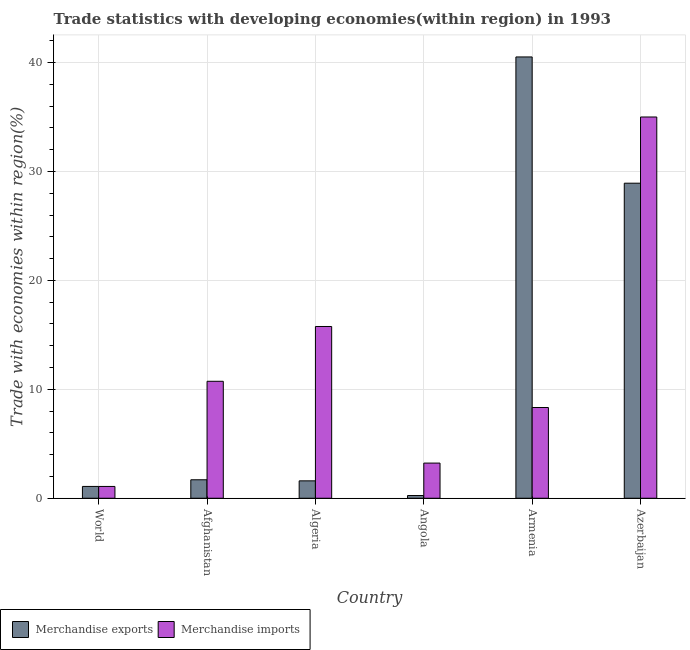How many different coloured bars are there?
Provide a succinct answer. 2. How many groups of bars are there?
Your answer should be very brief. 6. How many bars are there on the 3rd tick from the left?
Provide a short and direct response. 2. How many bars are there on the 4th tick from the right?
Offer a very short reply. 2. What is the label of the 2nd group of bars from the left?
Keep it short and to the point. Afghanistan. What is the merchandise imports in Azerbaijan?
Your response must be concise. 35. Across all countries, what is the maximum merchandise imports?
Your answer should be compact. 35. Across all countries, what is the minimum merchandise imports?
Offer a very short reply. 1.08. In which country was the merchandise exports maximum?
Offer a terse response. Armenia. What is the total merchandise exports in the graph?
Offer a terse response. 74.07. What is the difference between the merchandise exports in Armenia and that in World?
Provide a succinct answer. 39.43. What is the difference between the merchandise imports in Algeria and the merchandise exports in World?
Provide a short and direct response. 14.68. What is the average merchandise exports per country?
Provide a short and direct response. 12.35. What is the difference between the merchandise imports and merchandise exports in World?
Offer a terse response. -0. In how many countries, is the merchandise exports greater than 40 %?
Make the answer very short. 1. What is the ratio of the merchandise imports in Armenia to that in Azerbaijan?
Your response must be concise. 0.24. Is the merchandise imports in Angola less than that in Armenia?
Your answer should be compact. Yes. Is the difference between the merchandise imports in Afghanistan and Armenia greater than the difference between the merchandise exports in Afghanistan and Armenia?
Offer a very short reply. Yes. What is the difference between the highest and the second highest merchandise imports?
Offer a very short reply. 19.23. What is the difference between the highest and the lowest merchandise exports?
Make the answer very short. 40.27. In how many countries, is the merchandise exports greater than the average merchandise exports taken over all countries?
Offer a very short reply. 2. Is the sum of the merchandise exports in Algeria and Armenia greater than the maximum merchandise imports across all countries?
Provide a short and direct response. Yes. What does the 1st bar from the left in Algeria represents?
Ensure brevity in your answer.  Merchandise exports. What does the 1st bar from the right in World represents?
Your answer should be very brief. Merchandise imports. How many bars are there?
Provide a succinct answer. 12. Are all the bars in the graph horizontal?
Keep it short and to the point. No. How many countries are there in the graph?
Offer a terse response. 6. Does the graph contain grids?
Your answer should be very brief. Yes. Where does the legend appear in the graph?
Provide a short and direct response. Bottom left. How many legend labels are there?
Make the answer very short. 2. How are the legend labels stacked?
Ensure brevity in your answer.  Horizontal. What is the title of the graph?
Offer a terse response. Trade statistics with developing economies(within region) in 1993. What is the label or title of the X-axis?
Ensure brevity in your answer.  Country. What is the label or title of the Y-axis?
Offer a terse response. Trade with economies within region(%). What is the Trade with economies within region(%) in Merchandise exports in World?
Provide a short and direct response. 1.08. What is the Trade with economies within region(%) in Merchandise imports in World?
Provide a succinct answer. 1.08. What is the Trade with economies within region(%) of Merchandise exports in Afghanistan?
Your answer should be very brief. 1.7. What is the Trade with economies within region(%) of Merchandise imports in Afghanistan?
Provide a short and direct response. 10.74. What is the Trade with economies within region(%) of Merchandise exports in Algeria?
Make the answer very short. 1.6. What is the Trade with economies within region(%) in Merchandise imports in Algeria?
Your answer should be very brief. 15.77. What is the Trade with economies within region(%) of Merchandise exports in Angola?
Your response must be concise. 0.25. What is the Trade with economies within region(%) of Merchandise imports in Angola?
Keep it short and to the point. 3.23. What is the Trade with economies within region(%) of Merchandise exports in Armenia?
Your answer should be compact. 40.52. What is the Trade with economies within region(%) in Merchandise imports in Armenia?
Offer a very short reply. 8.33. What is the Trade with economies within region(%) in Merchandise exports in Azerbaijan?
Make the answer very short. 28.93. What is the Trade with economies within region(%) in Merchandise imports in Azerbaijan?
Make the answer very short. 35. Across all countries, what is the maximum Trade with economies within region(%) of Merchandise exports?
Offer a very short reply. 40.52. Across all countries, what is the maximum Trade with economies within region(%) of Merchandise imports?
Your answer should be very brief. 35. Across all countries, what is the minimum Trade with economies within region(%) in Merchandise exports?
Your answer should be very brief. 0.25. Across all countries, what is the minimum Trade with economies within region(%) of Merchandise imports?
Your answer should be very brief. 1.08. What is the total Trade with economies within region(%) in Merchandise exports in the graph?
Your answer should be very brief. 74.07. What is the total Trade with economies within region(%) of Merchandise imports in the graph?
Your response must be concise. 74.15. What is the difference between the Trade with economies within region(%) in Merchandise exports in World and that in Afghanistan?
Ensure brevity in your answer.  -0.61. What is the difference between the Trade with economies within region(%) of Merchandise imports in World and that in Afghanistan?
Keep it short and to the point. -9.65. What is the difference between the Trade with economies within region(%) of Merchandise exports in World and that in Algeria?
Your response must be concise. -0.51. What is the difference between the Trade with economies within region(%) in Merchandise imports in World and that in Algeria?
Your response must be concise. -14.69. What is the difference between the Trade with economies within region(%) of Merchandise exports in World and that in Angola?
Your response must be concise. 0.84. What is the difference between the Trade with economies within region(%) of Merchandise imports in World and that in Angola?
Ensure brevity in your answer.  -2.14. What is the difference between the Trade with economies within region(%) in Merchandise exports in World and that in Armenia?
Provide a short and direct response. -39.43. What is the difference between the Trade with economies within region(%) of Merchandise imports in World and that in Armenia?
Offer a terse response. -7.25. What is the difference between the Trade with economies within region(%) of Merchandise exports in World and that in Azerbaijan?
Provide a short and direct response. -27.84. What is the difference between the Trade with economies within region(%) of Merchandise imports in World and that in Azerbaijan?
Provide a short and direct response. -33.92. What is the difference between the Trade with economies within region(%) in Merchandise exports in Afghanistan and that in Algeria?
Provide a short and direct response. 0.1. What is the difference between the Trade with economies within region(%) of Merchandise imports in Afghanistan and that in Algeria?
Ensure brevity in your answer.  -5.03. What is the difference between the Trade with economies within region(%) in Merchandise exports in Afghanistan and that in Angola?
Your response must be concise. 1.45. What is the difference between the Trade with economies within region(%) in Merchandise imports in Afghanistan and that in Angola?
Offer a terse response. 7.51. What is the difference between the Trade with economies within region(%) of Merchandise exports in Afghanistan and that in Armenia?
Make the answer very short. -38.82. What is the difference between the Trade with economies within region(%) in Merchandise imports in Afghanistan and that in Armenia?
Your response must be concise. 2.41. What is the difference between the Trade with economies within region(%) of Merchandise exports in Afghanistan and that in Azerbaijan?
Give a very brief answer. -27.23. What is the difference between the Trade with economies within region(%) of Merchandise imports in Afghanistan and that in Azerbaijan?
Offer a very short reply. -24.27. What is the difference between the Trade with economies within region(%) in Merchandise exports in Algeria and that in Angola?
Ensure brevity in your answer.  1.35. What is the difference between the Trade with economies within region(%) in Merchandise imports in Algeria and that in Angola?
Make the answer very short. 12.54. What is the difference between the Trade with economies within region(%) of Merchandise exports in Algeria and that in Armenia?
Provide a short and direct response. -38.92. What is the difference between the Trade with economies within region(%) of Merchandise imports in Algeria and that in Armenia?
Provide a succinct answer. 7.44. What is the difference between the Trade with economies within region(%) in Merchandise exports in Algeria and that in Azerbaijan?
Keep it short and to the point. -27.33. What is the difference between the Trade with economies within region(%) in Merchandise imports in Algeria and that in Azerbaijan?
Give a very brief answer. -19.23. What is the difference between the Trade with economies within region(%) of Merchandise exports in Angola and that in Armenia?
Keep it short and to the point. -40.27. What is the difference between the Trade with economies within region(%) in Merchandise imports in Angola and that in Armenia?
Give a very brief answer. -5.1. What is the difference between the Trade with economies within region(%) in Merchandise exports in Angola and that in Azerbaijan?
Provide a short and direct response. -28.68. What is the difference between the Trade with economies within region(%) of Merchandise imports in Angola and that in Azerbaijan?
Your response must be concise. -31.78. What is the difference between the Trade with economies within region(%) in Merchandise exports in Armenia and that in Azerbaijan?
Ensure brevity in your answer.  11.59. What is the difference between the Trade with economies within region(%) of Merchandise imports in Armenia and that in Azerbaijan?
Make the answer very short. -26.67. What is the difference between the Trade with economies within region(%) of Merchandise exports in World and the Trade with economies within region(%) of Merchandise imports in Afghanistan?
Your answer should be very brief. -9.65. What is the difference between the Trade with economies within region(%) of Merchandise exports in World and the Trade with economies within region(%) of Merchandise imports in Algeria?
Give a very brief answer. -14.68. What is the difference between the Trade with economies within region(%) in Merchandise exports in World and the Trade with economies within region(%) in Merchandise imports in Angola?
Offer a terse response. -2.14. What is the difference between the Trade with economies within region(%) in Merchandise exports in World and the Trade with economies within region(%) in Merchandise imports in Armenia?
Your response must be concise. -7.25. What is the difference between the Trade with economies within region(%) in Merchandise exports in World and the Trade with economies within region(%) in Merchandise imports in Azerbaijan?
Your answer should be compact. -33.92. What is the difference between the Trade with economies within region(%) of Merchandise exports in Afghanistan and the Trade with economies within region(%) of Merchandise imports in Algeria?
Provide a succinct answer. -14.07. What is the difference between the Trade with economies within region(%) of Merchandise exports in Afghanistan and the Trade with economies within region(%) of Merchandise imports in Angola?
Your answer should be compact. -1.53. What is the difference between the Trade with economies within region(%) of Merchandise exports in Afghanistan and the Trade with economies within region(%) of Merchandise imports in Armenia?
Ensure brevity in your answer.  -6.63. What is the difference between the Trade with economies within region(%) of Merchandise exports in Afghanistan and the Trade with economies within region(%) of Merchandise imports in Azerbaijan?
Keep it short and to the point. -33.31. What is the difference between the Trade with economies within region(%) of Merchandise exports in Algeria and the Trade with economies within region(%) of Merchandise imports in Angola?
Make the answer very short. -1.63. What is the difference between the Trade with economies within region(%) in Merchandise exports in Algeria and the Trade with economies within region(%) in Merchandise imports in Armenia?
Keep it short and to the point. -6.73. What is the difference between the Trade with economies within region(%) of Merchandise exports in Algeria and the Trade with economies within region(%) of Merchandise imports in Azerbaijan?
Offer a very short reply. -33.41. What is the difference between the Trade with economies within region(%) in Merchandise exports in Angola and the Trade with economies within region(%) in Merchandise imports in Armenia?
Your answer should be compact. -8.08. What is the difference between the Trade with economies within region(%) in Merchandise exports in Angola and the Trade with economies within region(%) in Merchandise imports in Azerbaijan?
Your answer should be very brief. -34.75. What is the difference between the Trade with economies within region(%) of Merchandise exports in Armenia and the Trade with economies within region(%) of Merchandise imports in Azerbaijan?
Your answer should be compact. 5.51. What is the average Trade with economies within region(%) of Merchandise exports per country?
Provide a succinct answer. 12.35. What is the average Trade with economies within region(%) of Merchandise imports per country?
Ensure brevity in your answer.  12.36. What is the difference between the Trade with economies within region(%) in Merchandise exports and Trade with economies within region(%) in Merchandise imports in World?
Your response must be concise. 0. What is the difference between the Trade with economies within region(%) of Merchandise exports and Trade with economies within region(%) of Merchandise imports in Afghanistan?
Make the answer very short. -9.04. What is the difference between the Trade with economies within region(%) of Merchandise exports and Trade with economies within region(%) of Merchandise imports in Algeria?
Your answer should be compact. -14.17. What is the difference between the Trade with economies within region(%) of Merchandise exports and Trade with economies within region(%) of Merchandise imports in Angola?
Offer a very short reply. -2.98. What is the difference between the Trade with economies within region(%) in Merchandise exports and Trade with economies within region(%) in Merchandise imports in Armenia?
Keep it short and to the point. 32.19. What is the difference between the Trade with economies within region(%) in Merchandise exports and Trade with economies within region(%) in Merchandise imports in Azerbaijan?
Provide a succinct answer. -6.08. What is the ratio of the Trade with economies within region(%) of Merchandise exports in World to that in Afghanistan?
Keep it short and to the point. 0.64. What is the ratio of the Trade with economies within region(%) in Merchandise imports in World to that in Afghanistan?
Give a very brief answer. 0.1. What is the ratio of the Trade with economies within region(%) of Merchandise exports in World to that in Algeria?
Offer a terse response. 0.68. What is the ratio of the Trade with economies within region(%) of Merchandise imports in World to that in Algeria?
Your response must be concise. 0.07. What is the ratio of the Trade with economies within region(%) in Merchandise exports in World to that in Angola?
Give a very brief answer. 4.35. What is the ratio of the Trade with economies within region(%) in Merchandise imports in World to that in Angola?
Keep it short and to the point. 0.34. What is the ratio of the Trade with economies within region(%) in Merchandise exports in World to that in Armenia?
Keep it short and to the point. 0.03. What is the ratio of the Trade with economies within region(%) in Merchandise imports in World to that in Armenia?
Provide a succinct answer. 0.13. What is the ratio of the Trade with economies within region(%) in Merchandise exports in World to that in Azerbaijan?
Ensure brevity in your answer.  0.04. What is the ratio of the Trade with economies within region(%) of Merchandise imports in World to that in Azerbaijan?
Your answer should be compact. 0.03. What is the ratio of the Trade with economies within region(%) of Merchandise exports in Afghanistan to that in Algeria?
Your answer should be very brief. 1.06. What is the ratio of the Trade with economies within region(%) of Merchandise imports in Afghanistan to that in Algeria?
Provide a short and direct response. 0.68. What is the ratio of the Trade with economies within region(%) of Merchandise exports in Afghanistan to that in Angola?
Offer a very short reply. 6.8. What is the ratio of the Trade with economies within region(%) in Merchandise imports in Afghanistan to that in Angola?
Offer a very short reply. 3.33. What is the ratio of the Trade with economies within region(%) of Merchandise exports in Afghanistan to that in Armenia?
Offer a terse response. 0.04. What is the ratio of the Trade with economies within region(%) of Merchandise imports in Afghanistan to that in Armenia?
Your answer should be compact. 1.29. What is the ratio of the Trade with economies within region(%) in Merchandise exports in Afghanistan to that in Azerbaijan?
Your answer should be very brief. 0.06. What is the ratio of the Trade with economies within region(%) in Merchandise imports in Afghanistan to that in Azerbaijan?
Ensure brevity in your answer.  0.31. What is the ratio of the Trade with economies within region(%) in Merchandise exports in Algeria to that in Angola?
Your response must be concise. 6.4. What is the ratio of the Trade with economies within region(%) in Merchandise imports in Algeria to that in Angola?
Offer a very short reply. 4.89. What is the ratio of the Trade with economies within region(%) in Merchandise exports in Algeria to that in Armenia?
Ensure brevity in your answer.  0.04. What is the ratio of the Trade with economies within region(%) in Merchandise imports in Algeria to that in Armenia?
Offer a terse response. 1.89. What is the ratio of the Trade with economies within region(%) of Merchandise exports in Algeria to that in Azerbaijan?
Keep it short and to the point. 0.06. What is the ratio of the Trade with economies within region(%) of Merchandise imports in Algeria to that in Azerbaijan?
Your response must be concise. 0.45. What is the ratio of the Trade with economies within region(%) in Merchandise exports in Angola to that in Armenia?
Your answer should be very brief. 0.01. What is the ratio of the Trade with economies within region(%) of Merchandise imports in Angola to that in Armenia?
Offer a very short reply. 0.39. What is the ratio of the Trade with economies within region(%) of Merchandise exports in Angola to that in Azerbaijan?
Your answer should be compact. 0.01. What is the ratio of the Trade with economies within region(%) in Merchandise imports in Angola to that in Azerbaijan?
Offer a terse response. 0.09. What is the ratio of the Trade with economies within region(%) in Merchandise exports in Armenia to that in Azerbaijan?
Provide a short and direct response. 1.4. What is the ratio of the Trade with economies within region(%) in Merchandise imports in Armenia to that in Azerbaijan?
Offer a terse response. 0.24. What is the difference between the highest and the second highest Trade with economies within region(%) in Merchandise exports?
Your response must be concise. 11.59. What is the difference between the highest and the second highest Trade with economies within region(%) in Merchandise imports?
Your response must be concise. 19.23. What is the difference between the highest and the lowest Trade with economies within region(%) of Merchandise exports?
Give a very brief answer. 40.27. What is the difference between the highest and the lowest Trade with economies within region(%) of Merchandise imports?
Give a very brief answer. 33.92. 